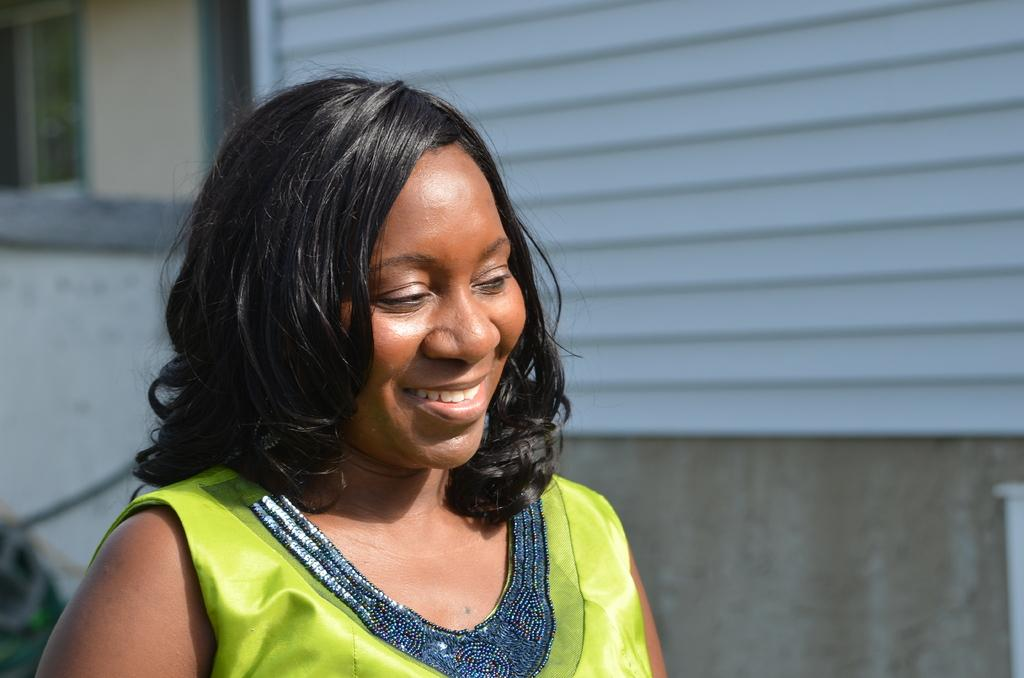Who is present in the image? There is a woman in the image. What is the woman wearing? The woman is wearing a green dress. What can be seen in the background of the image? There is a building in the background of the image. Where is the window located in the image? There is a window visible in the top left corner of the image. What type of magic is the woman performing in the image? There is no indication of magic or any magical activity in the image. 